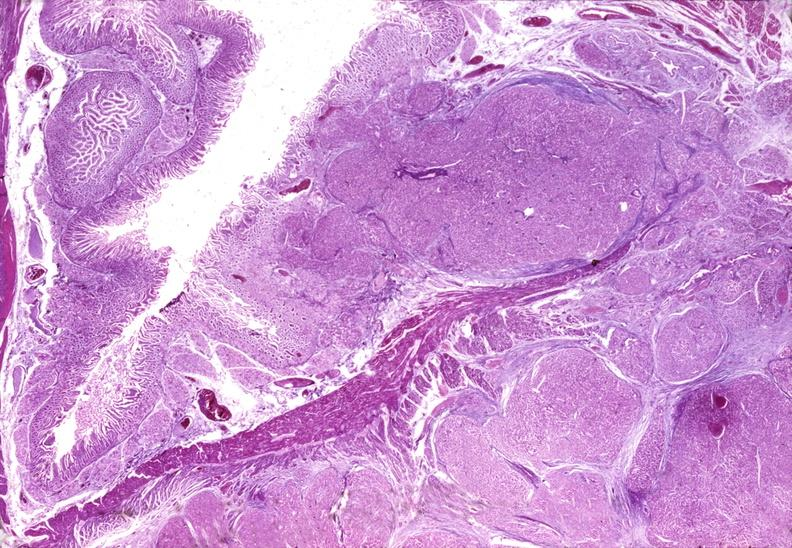s a barely seen vascular mass extruding from occipital region of skull arms and legs present?
Answer the question using a single word or phrase. No 